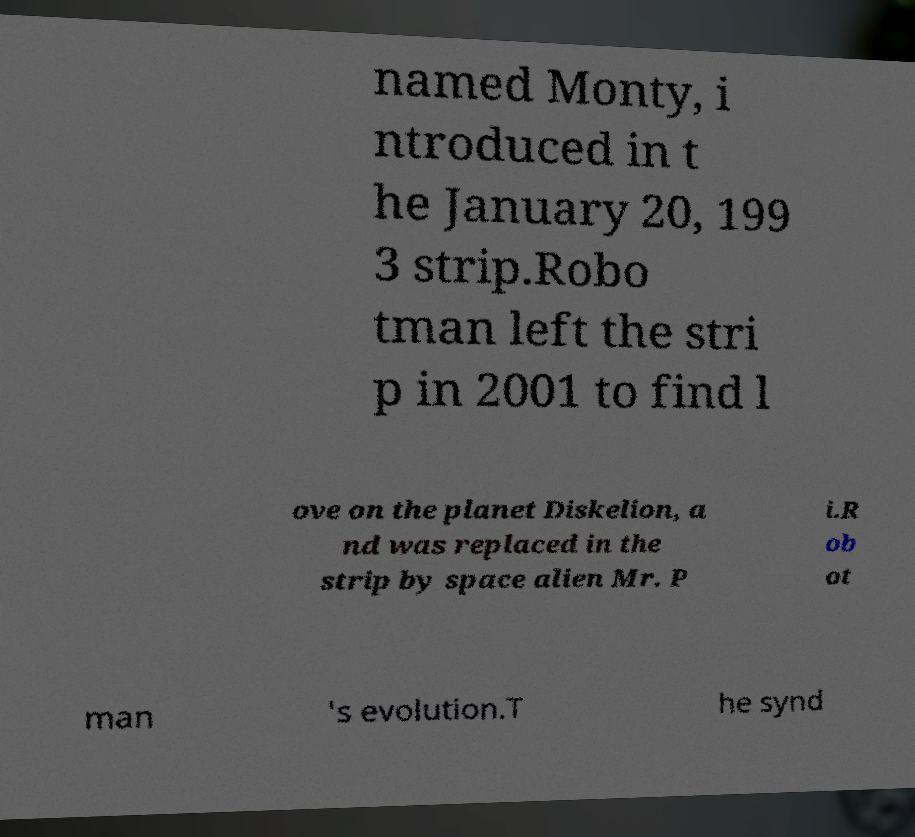Could you extract and type out the text from this image? named Monty, i ntroduced in t he January 20, 199 3 strip.Robo tman left the stri p in 2001 to find l ove on the planet Diskelion, a nd was replaced in the strip by space alien Mr. P i.R ob ot man 's evolution.T he synd 